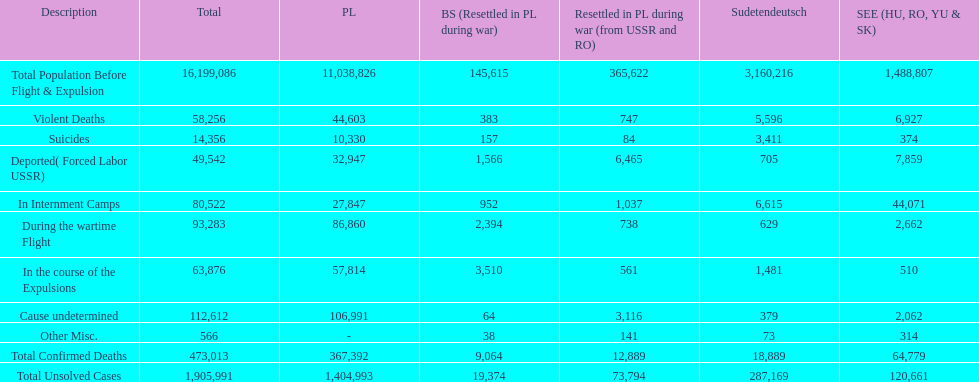How do suicides in poland and sudetendeutsch differ? 6919. 